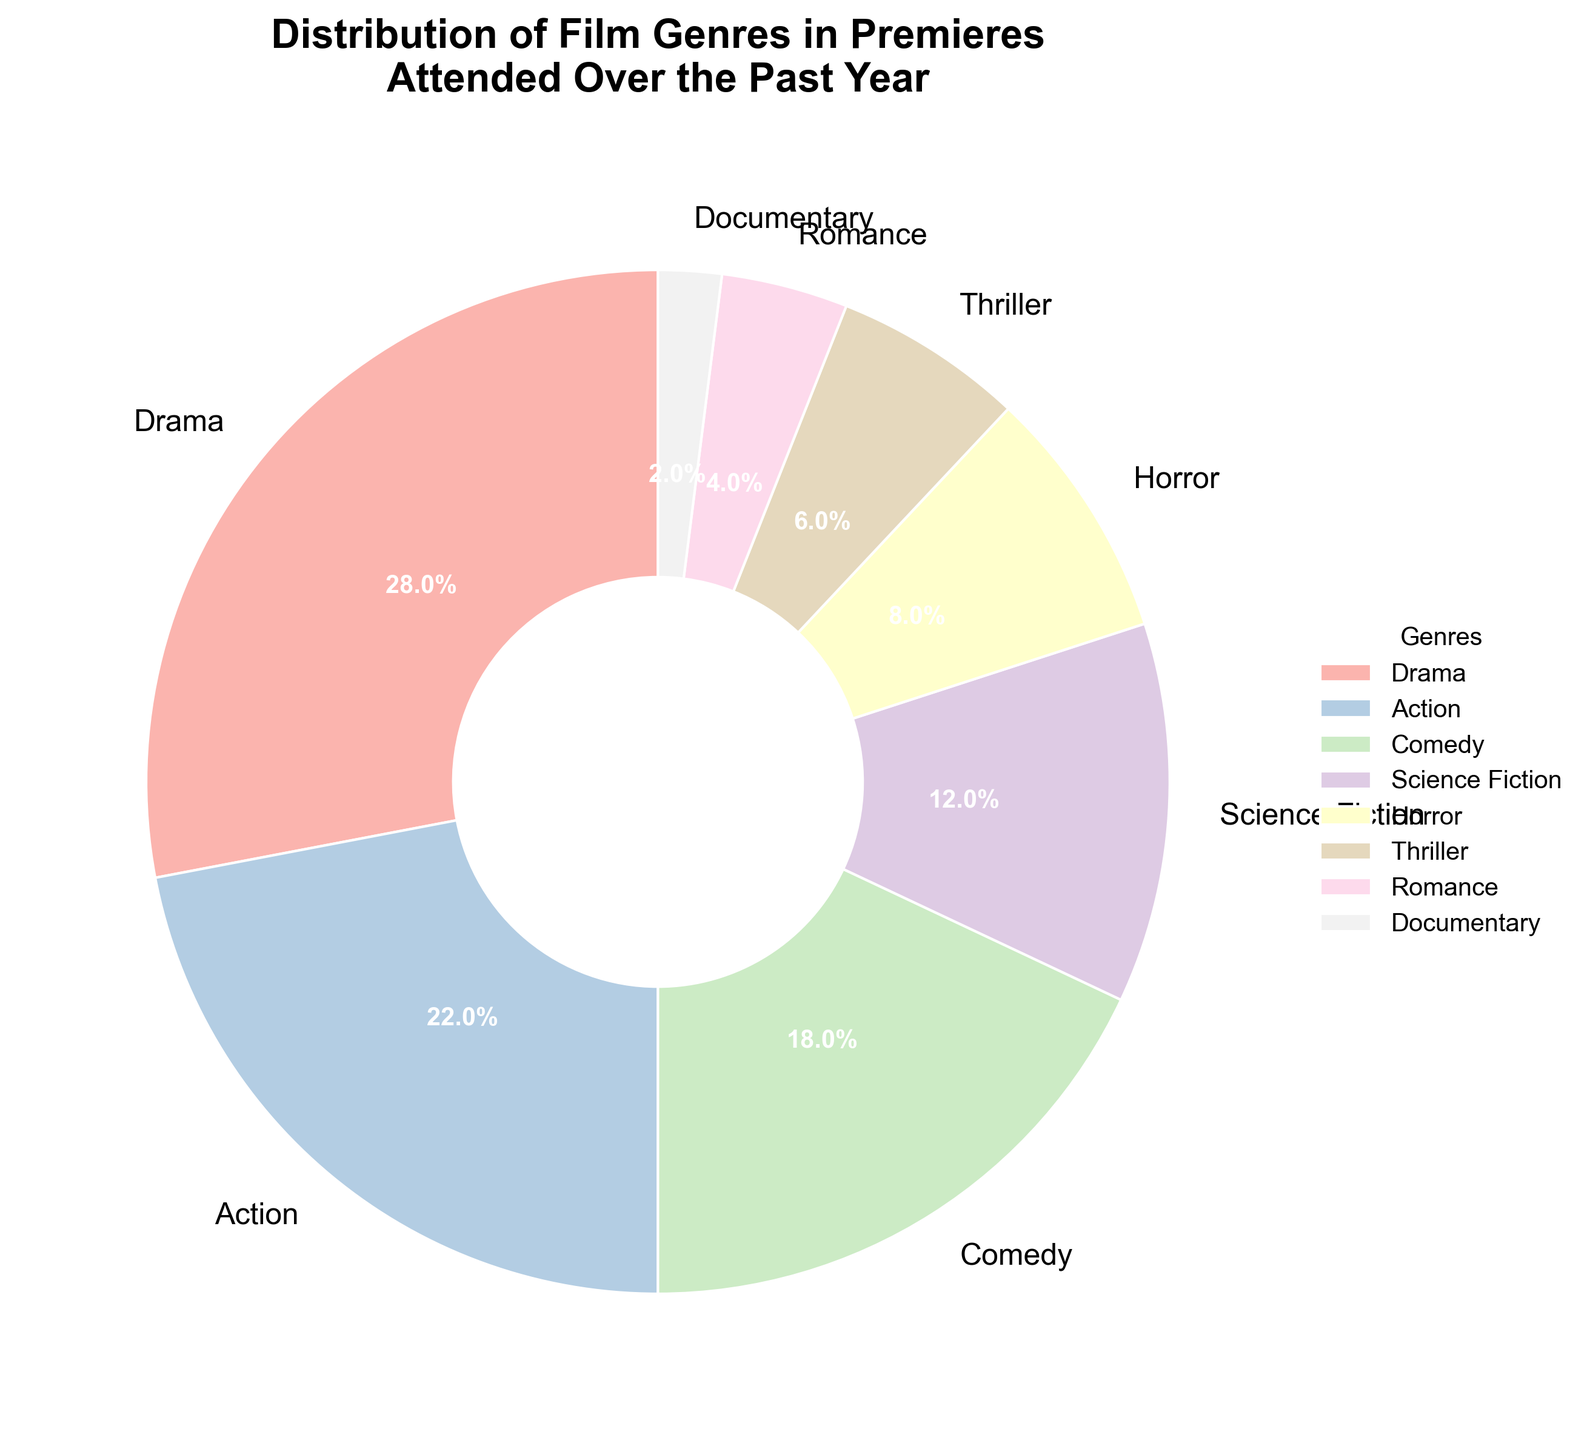What percentage of the films attended were either Drama or Action? To find the combined percentage for Drama and Action, we add their individual percentages: 28% (Drama) + 22% (Action) = 50%.
Answer: 50% Which genre accounts for the smallest proportion of films attended? The genre with the smallest percentage is Documentary, which has a 2% share.
Answer: Documentary How much larger is the percentage of Drama films compared to Horror films? To determine this, we subtract the percentage of Horror films (8%) from the percentage of Drama films (28%): 28% - 8% = 20%.
Answer: 20% Which genre is more popular, Comedy or Science Fiction, and by how much? Comedy has an 18% share, while Science Fiction has 12%. Subtracting the smaller percentage from the larger gives 18% - 12% = 6%. Thus, Comedy is more popular by 6%.
Answer: Comedy by 6% What percentage of films belong to genres other than Drama and Action? First, combine the percentages of Drama and Action: 28% + 22% = 50%. Then, subtract this from the total 100% to get the percentage for other genres: 100% - 50% = 50%.
Answer: 50% How do the combined percentages of Science Fiction and Horror compare to the percentage of Comedy? Add the percentages of Science Fiction and Horror: 12% + 8% = 20%. The percentage of Comedy is 18%. Therefore, the combined percentage of Science Fiction and Horror (20%) is 2% greater than Comedy (18%).
Answer: 2% greater What is the total percentage for Thriller and Romance genres combined? Add the percentages of Thriller and Romance: 6% (Thriller) + 4% (Romance) = 10%.
Answer: 10% If you combine the percentages of the three least popular genres, what do you get? The three least popular genres are Documentary (2%), Romance (4%), and Thriller (6%). Adding these together: 2% + 4% + 6% = 12%.
Answer: 12% Is Action more popular than Science Fiction and Comedy combined? First, combine the percentages of Science Fiction and Comedy: 12% + 18% = 30%. Since Action has a 22% share, 30% (Comedy + Science Fiction) is indeed greater than 22% (Action).
Answer: No What visual attributes are used to distinguish different genres in the pie chart? Different genres are distinguished by colors (each genre has a different pastel color), the labels showing genre names, and the percentages displayed on the pie slices.
Answer: Colors, labels, percentages 